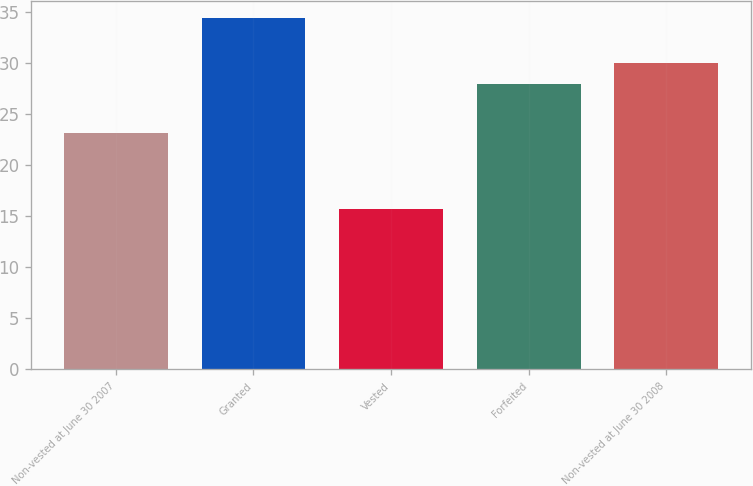<chart> <loc_0><loc_0><loc_500><loc_500><bar_chart><fcel>Non-vested at June 30 2007<fcel>Granted<fcel>Vested<fcel>Forfeited<fcel>Non-vested at June 30 2008<nl><fcel>23.19<fcel>34.45<fcel>15.74<fcel>27.94<fcel>30<nl></chart> 